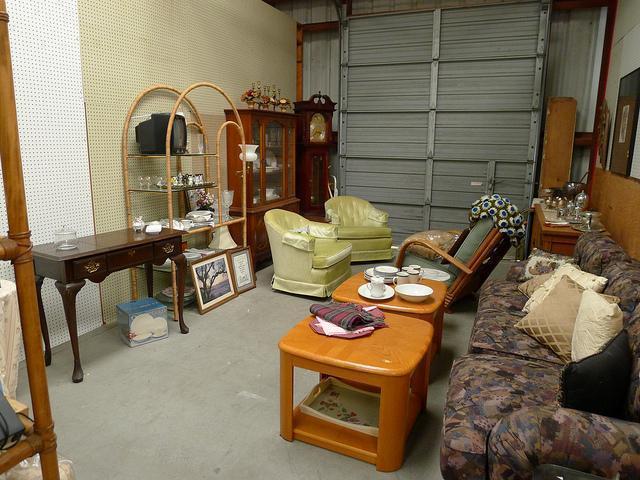Based on the door this furniture is most likely located in what?
Make your selection from the four choices given to correctly answer the question.
Options: Storage unit, living room, barn, bedroom. Storage unit. 